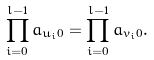Convert formula to latex. <formula><loc_0><loc_0><loc_500><loc_500>\prod _ { i = 0 } ^ { l - 1 } a _ { { u _ { i } } 0 } = \prod _ { i = 0 } ^ { l - 1 } a _ { { v _ { i } } 0 } .</formula> 